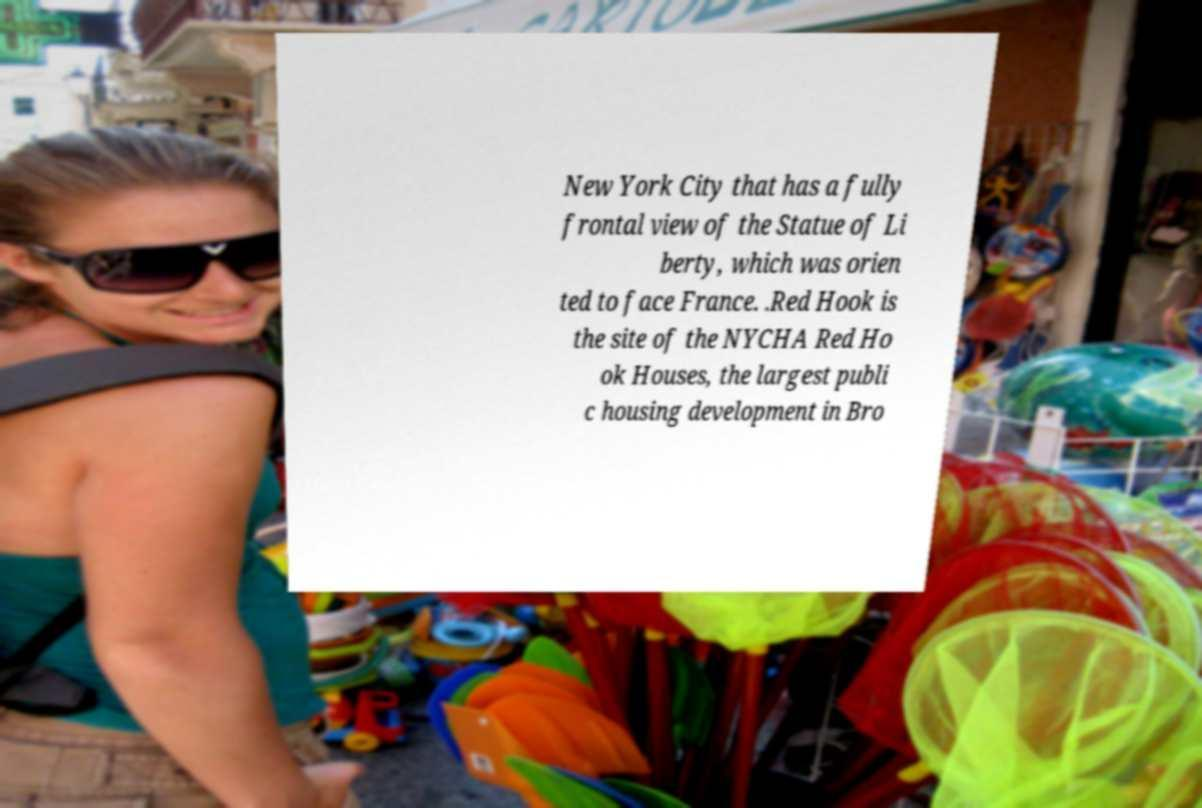Could you assist in decoding the text presented in this image and type it out clearly? New York City that has a fully frontal view of the Statue of Li berty, which was orien ted to face France. .Red Hook is the site of the NYCHA Red Ho ok Houses, the largest publi c housing development in Bro 